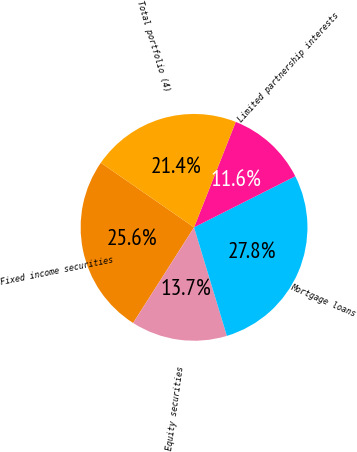<chart> <loc_0><loc_0><loc_500><loc_500><pie_chart><fcel>Fixed income securities<fcel>Equity securities<fcel>Mortgage loans<fcel>Limited partnership interests<fcel>Total portfolio (4)<nl><fcel>25.62%<fcel>13.7%<fcel>27.76%<fcel>11.57%<fcel>21.35%<nl></chart> 